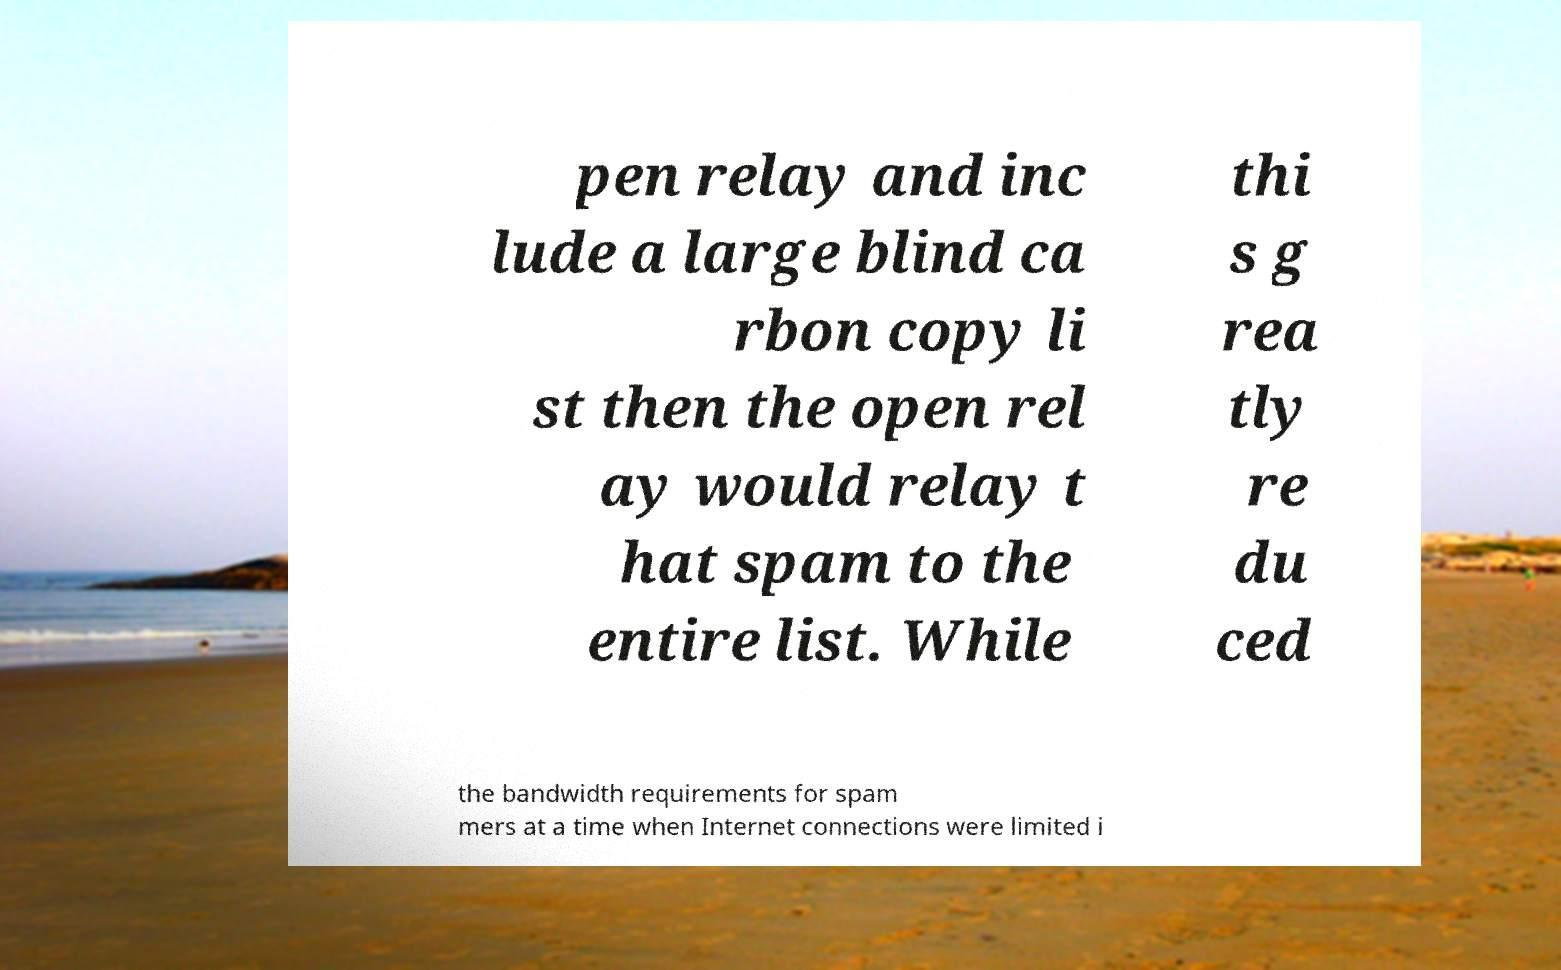I need the written content from this picture converted into text. Can you do that? pen relay and inc lude a large blind ca rbon copy li st then the open rel ay would relay t hat spam to the entire list. While thi s g rea tly re du ced the bandwidth requirements for spam mers at a time when Internet connections were limited i 